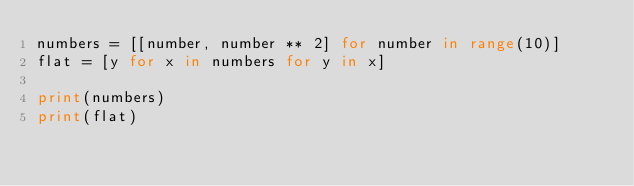<code> <loc_0><loc_0><loc_500><loc_500><_Python_>numbers = [[number, number ** 2] for number in range(10)]
flat = [y for x in numbers for y in x]

print(numbers)
print(flat)
</code> 